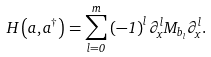<formula> <loc_0><loc_0><loc_500><loc_500>H \left ( a _ { } , a _ { } ^ { \dagger } \right ) = \sum _ { l = 0 } ^ { m } \left ( - 1 \right ) ^ { l } \partial _ { x } ^ { l } M _ { b _ { l } } \partial _ { x } ^ { l } .</formula> 